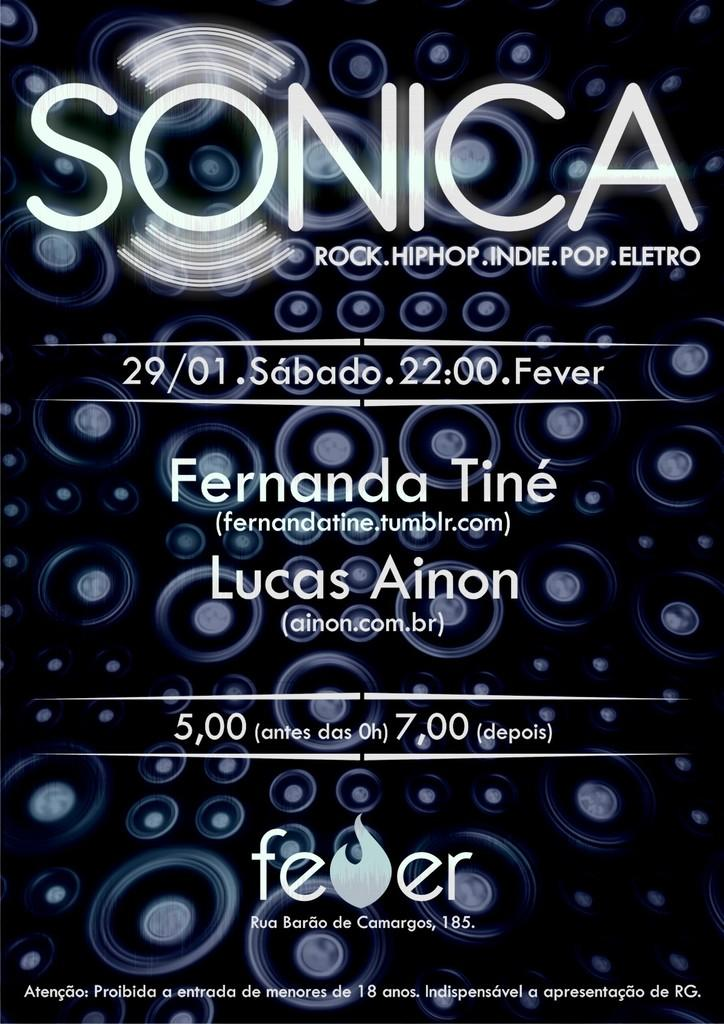<image>
Offer a succinct explanation of the picture presented. A poster for Sonica in black and white and grey. 